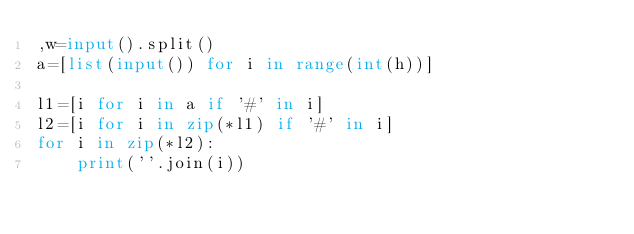<code> <loc_0><loc_0><loc_500><loc_500><_Python_>,w=input().split()
a=[list(input()) for i in range(int(h))]

l1=[i for i in a if '#' in i]
l2=[i for i in zip(*l1) if '#' in i]
for i in zip(*l2):
    print(''.join(i))</code> 